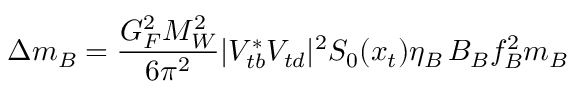<formula> <loc_0><loc_0><loc_500><loc_500>\Delta m _ { B } = \frac { G _ { F } ^ { 2 } M _ { W } ^ { 2 } } { 6 \pi ^ { 2 } } | V _ { t b } ^ { * } V _ { t d } | ^ { 2 } S _ { 0 } ( x _ { t } ) \eta _ { B } \, B _ { B } f _ { B } ^ { 2 } m _ { B }</formula> 